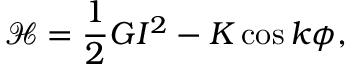Convert formula to latex. <formula><loc_0><loc_0><loc_500><loc_500>\mathcal { H } = \frac { 1 } { 2 } G I ^ { 2 } - K \cos k \phi ,</formula> 